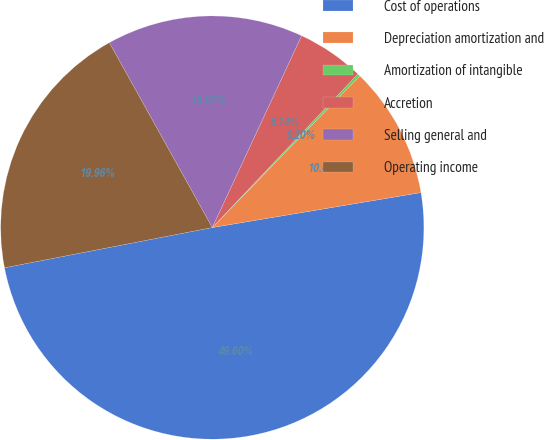Convert chart. <chart><loc_0><loc_0><loc_500><loc_500><pie_chart><fcel>Cost of operations<fcel>Depreciation amortization and<fcel>Amortization of intangible<fcel>Accretion<fcel>Selling general and<fcel>Operating income<nl><fcel>49.6%<fcel>10.08%<fcel>0.2%<fcel>5.14%<fcel>15.02%<fcel>19.96%<nl></chart> 